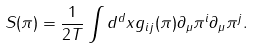<formula> <loc_0><loc_0><loc_500><loc_500>S ( \pi ) = \frac { 1 } { 2 T } \int d ^ { d } x g _ { i j } ( \pi ) \partial _ { \mu } { \pi ^ { i } } \partial _ { \mu } { \pi ^ { j } } .</formula> 